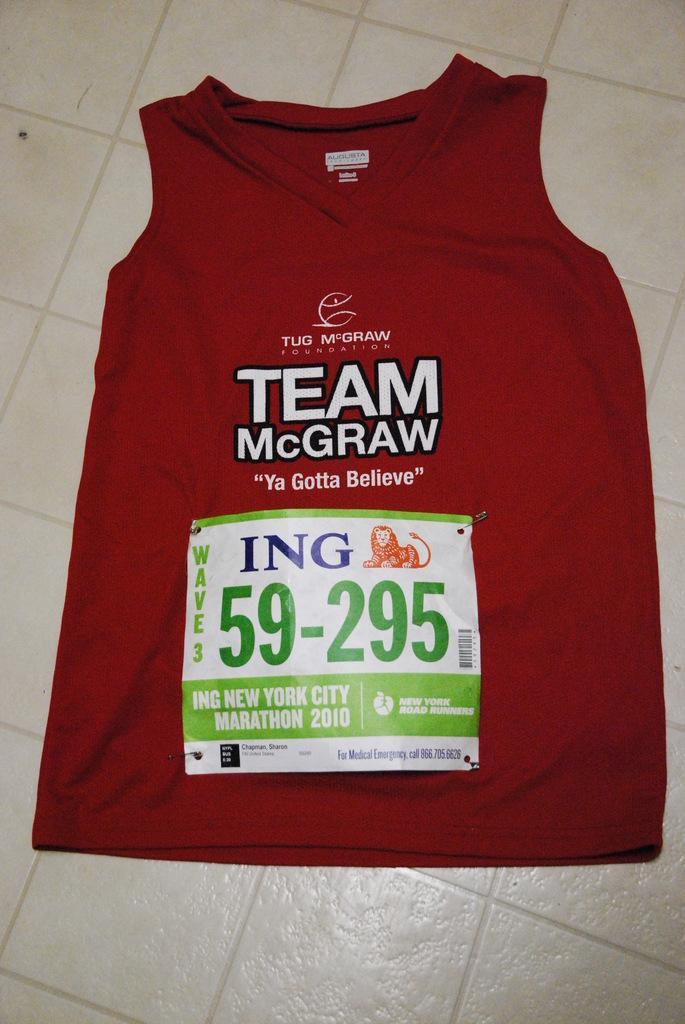Please provide a concise description of this image. It is a t-shirt on the floor in red color, there is the sticker on it. 